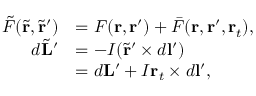<formula> <loc_0><loc_0><loc_500><loc_500>\begin{array} { r l } { \tilde { F } ( \tilde { r } , \tilde { r } ^ { \prime } ) } & { = F ( r , r ^ { \prime } ) + \bar { F } ( r , r ^ { \prime } , r _ { t } ) , } \\ { d \tilde { L } ^ { \prime } } & { = - I ( \tilde { r } ^ { \prime } \times d l ^ { \prime } ) } \\ & { = d L ^ { \prime } + I r _ { t } \times d l ^ { \prime } , } \end{array}</formula> 